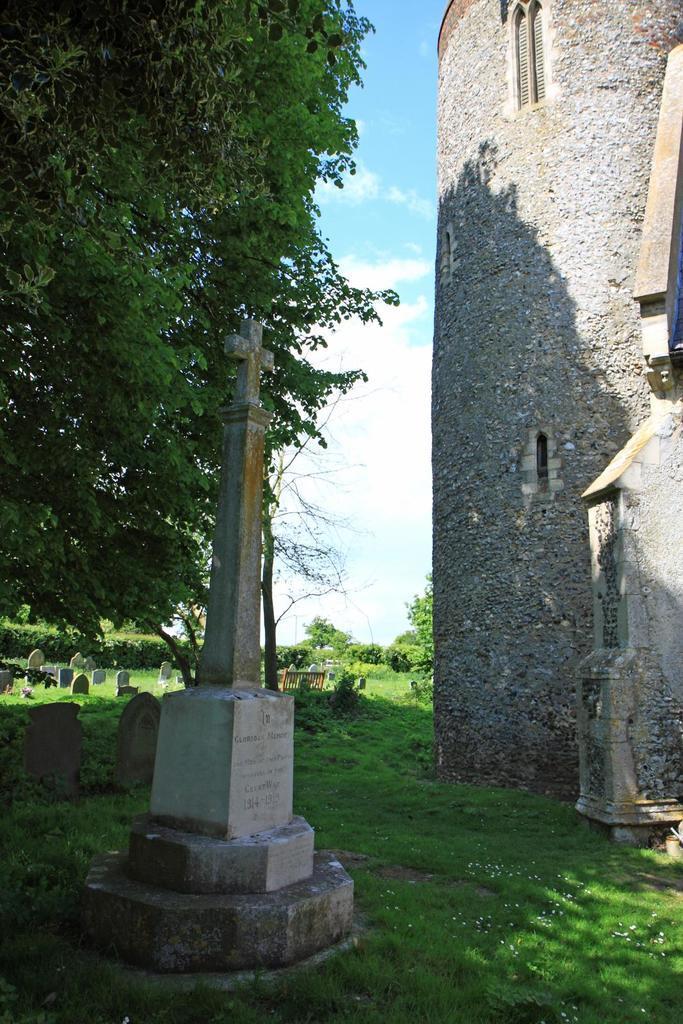Please provide a concise description of this image. In this image we can see some memorials with a cross on it. We can also see some trees, plants and the grass. On the right side we can see a building with windows and the sky which looks cloudy. 